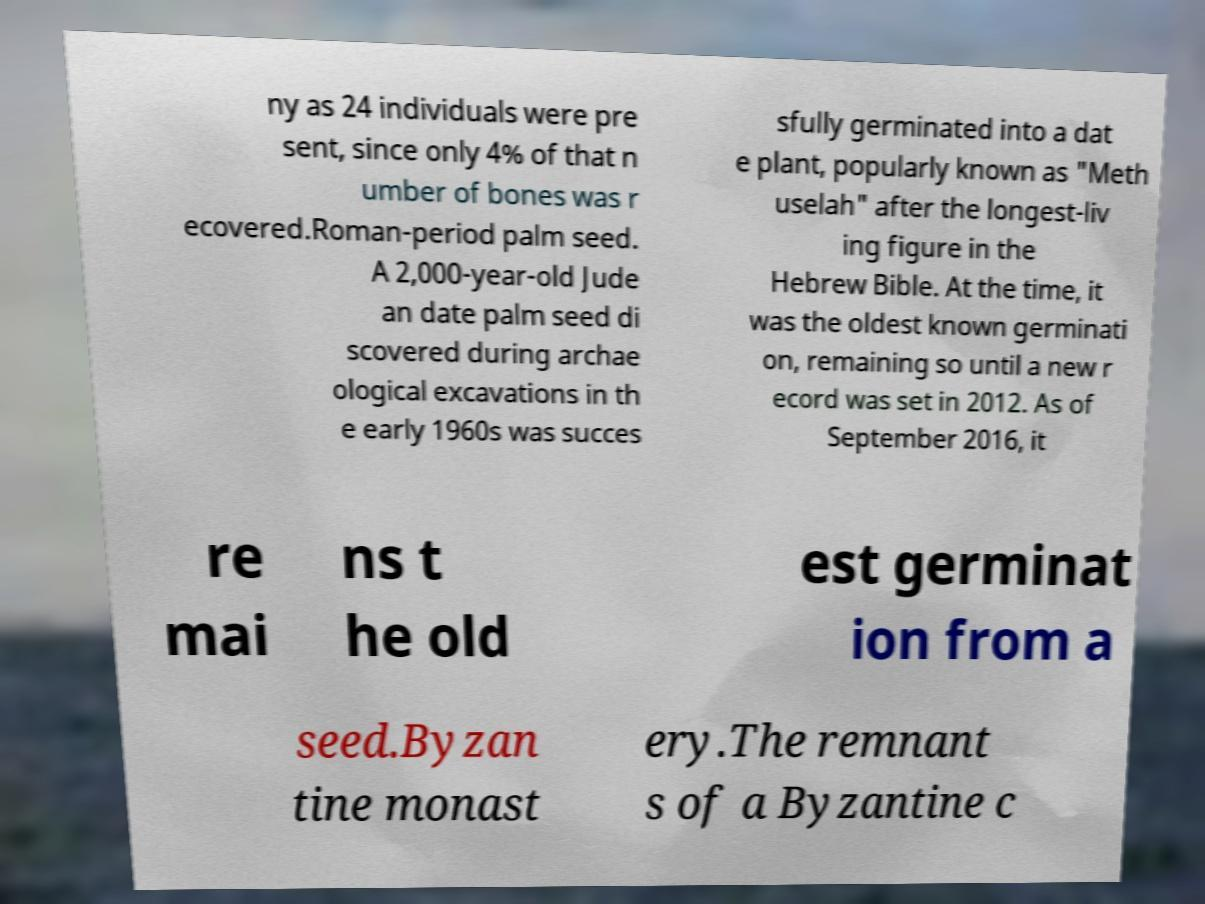Can you read and provide the text displayed in the image?This photo seems to have some interesting text. Can you extract and type it out for me? ny as 24 individuals were pre sent, since only 4% of that n umber of bones was r ecovered.Roman-period palm seed. A 2,000-year-old Jude an date palm seed di scovered during archae ological excavations in th e early 1960s was succes sfully germinated into a dat e plant, popularly known as "Meth uselah" after the longest-liv ing figure in the Hebrew Bible. At the time, it was the oldest known germinati on, remaining so until a new r ecord was set in 2012. As of September 2016, it re mai ns t he old est germinat ion from a seed.Byzan tine monast ery.The remnant s of a Byzantine c 